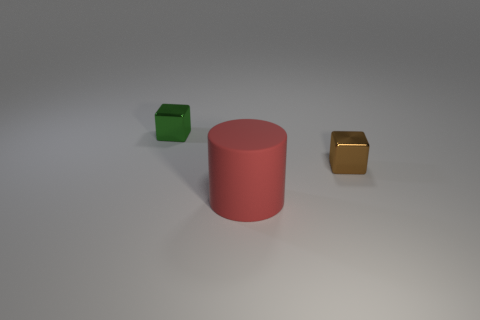What is the shape of the big red thing? The large red object in the image is cylindrical in shape, characterized by its circular base and height that extends vertically from the base, creating a three-dimensional form that looks like a can or tube. 